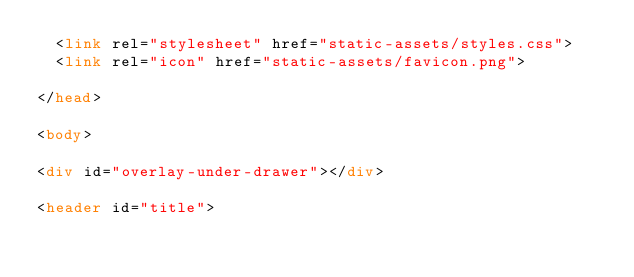<code> <loc_0><loc_0><loc_500><loc_500><_HTML_>  <link rel="stylesheet" href="static-assets/styles.css">
  <link rel="icon" href="static-assets/favicon.png">
  
</head>

<body>

<div id="overlay-under-drawer"></div>

<header id="title"></code> 